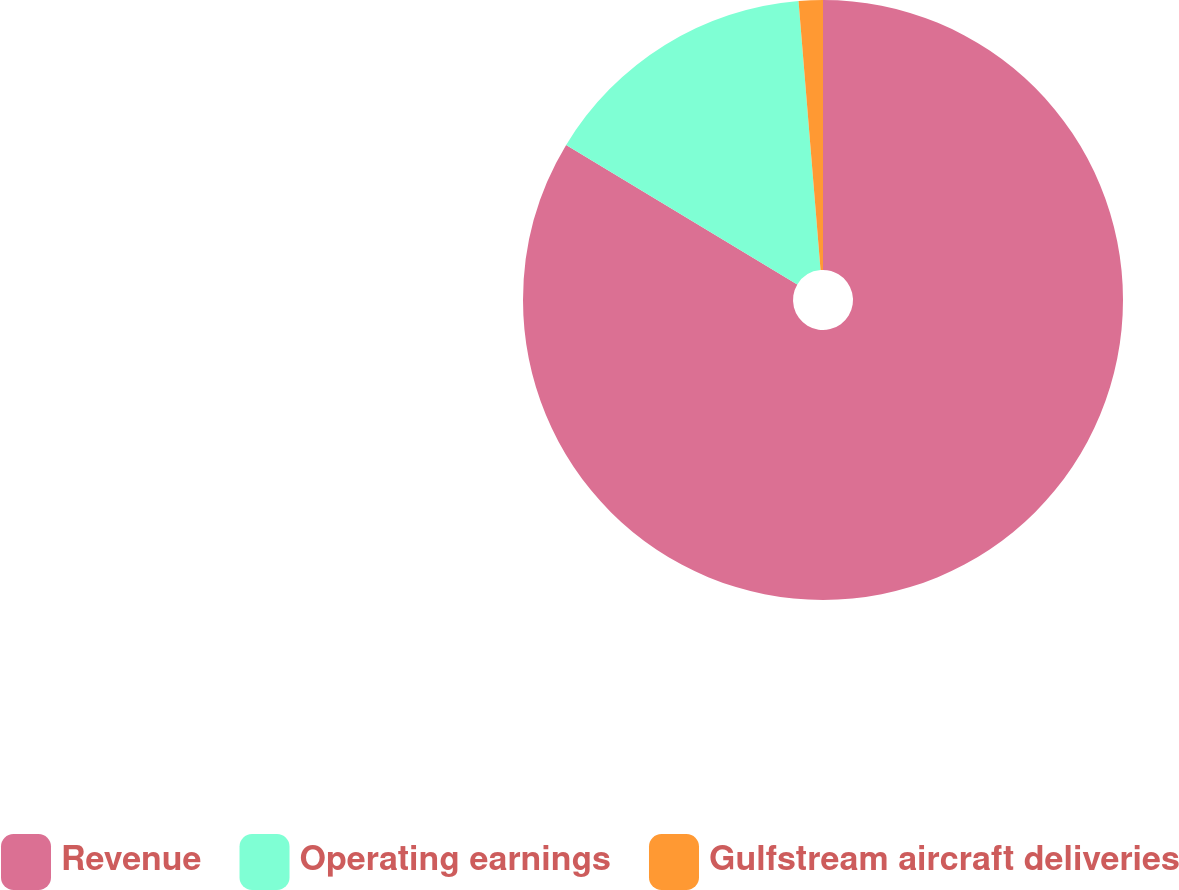Convert chart to OTSL. <chart><loc_0><loc_0><loc_500><loc_500><pie_chart><fcel>Revenue<fcel>Operating earnings<fcel>Gulfstream aircraft deliveries<nl><fcel>83.65%<fcel>15.06%<fcel>1.3%<nl></chart> 